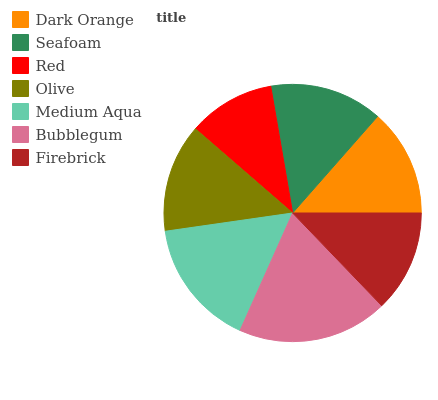Is Red the minimum?
Answer yes or no. Yes. Is Bubblegum the maximum?
Answer yes or no. Yes. Is Seafoam the minimum?
Answer yes or no. No. Is Seafoam the maximum?
Answer yes or no. No. Is Seafoam greater than Dark Orange?
Answer yes or no. Yes. Is Dark Orange less than Seafoam?
Answer yes or no. Yes. Is Dark Orange greater than Seafoam?
Answer yes or no. No. Is Seafoam less than Dark Orange?
Answer yes or no. No. Is Olive the high median?
Answer yes or no. Yes. Is Olive the low median?
Answer yes or no. Yes. Is Firebrick the high median?
Answer yes or no. No. Is Dark Orange the low median?
Answer yes or no. No. 